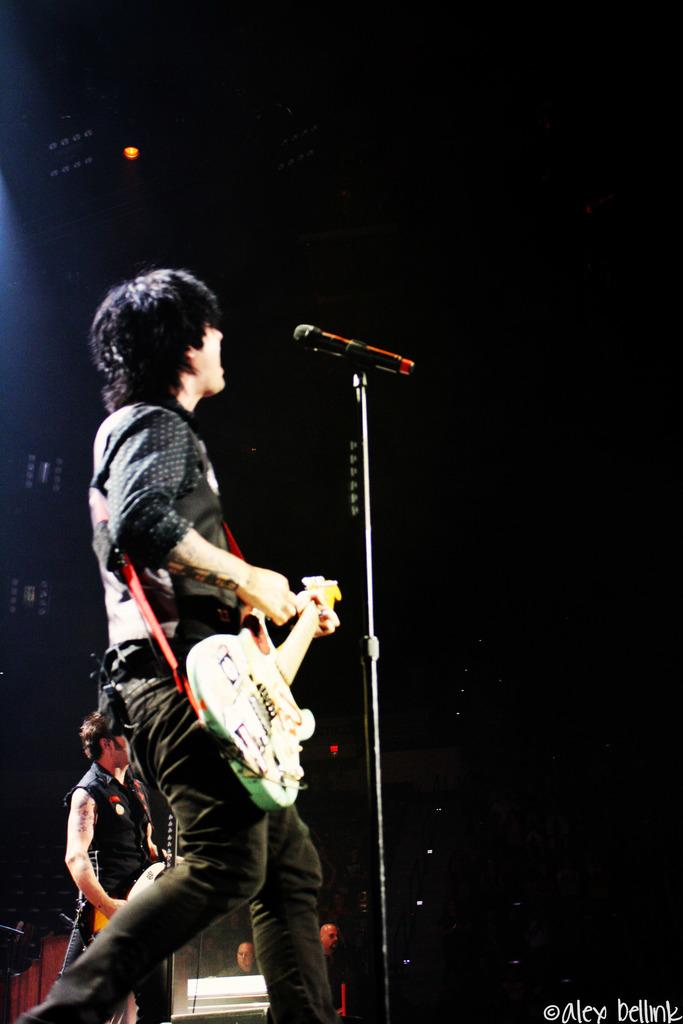What are the two men on the stage doing? The two men on the stage are playing guitar. What object is present to amplify their voices? There is a microphone present. Can you describe the background of the image? In the background, there are two persons standing. What type of bean is being grown on the farm in the image? There is no farm or bean present in the image; it features two men playing guitar on a stage. How many giants can be seen in the image? There are no giants present in the image. 